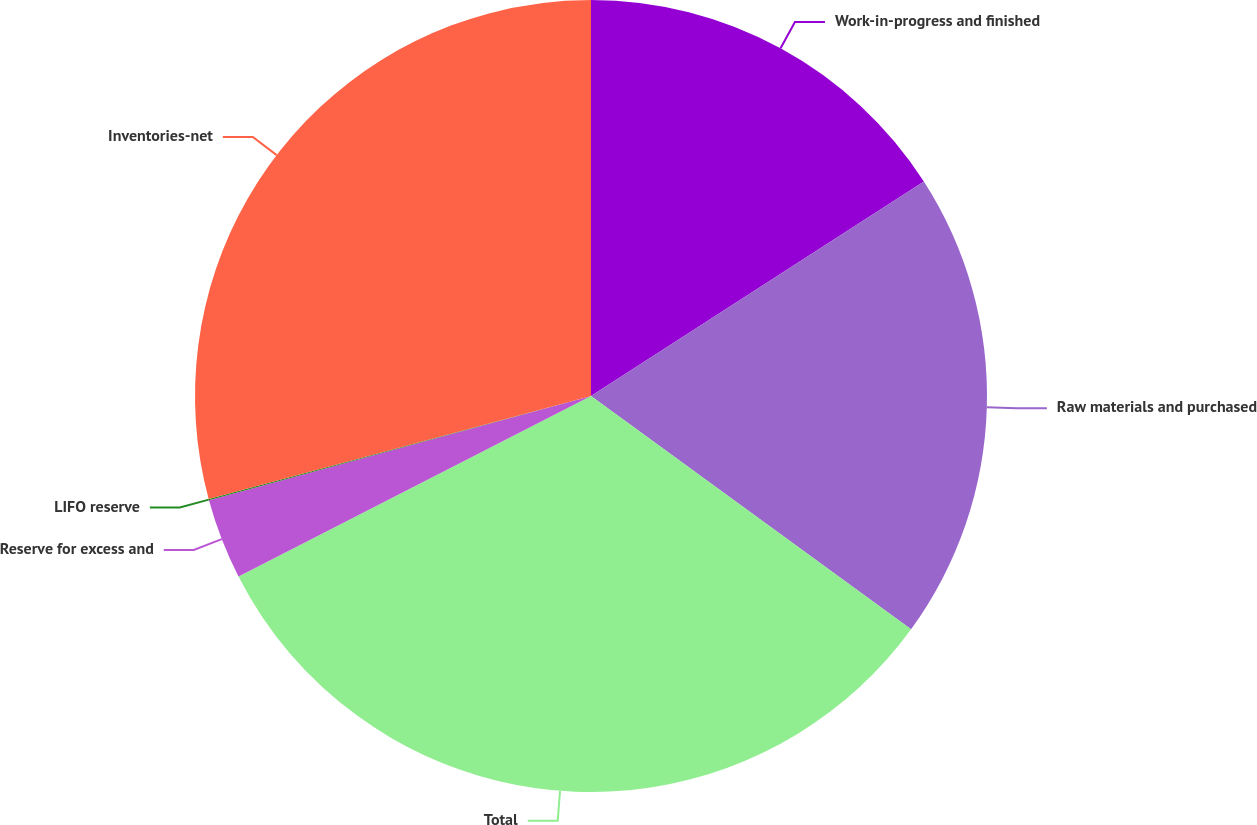<chart> <loc_0><loc_0><loc_500><loc_500><pie_chart><fcel>Work-in-progress and finished<fcel>Raw materials and purchased<fcel>Total<fcel>Reserve for excess and<fcel>LIFO reserve<fcel>Inventories-net<nl><fcel>15.89%<fcel>19.13%<fcel>32.45%<fcel>3.29%<fcel>0.05%<fcel>29.19%<nl></chart> 